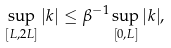<formula> <loc_0><loc_0><loc_500><loc_500>\sup _ { [ L , 2 L ] } | k | \leq \beta ^ { - 1 } \sup _ { [ 0 , L ] } | k | ,</formula> 